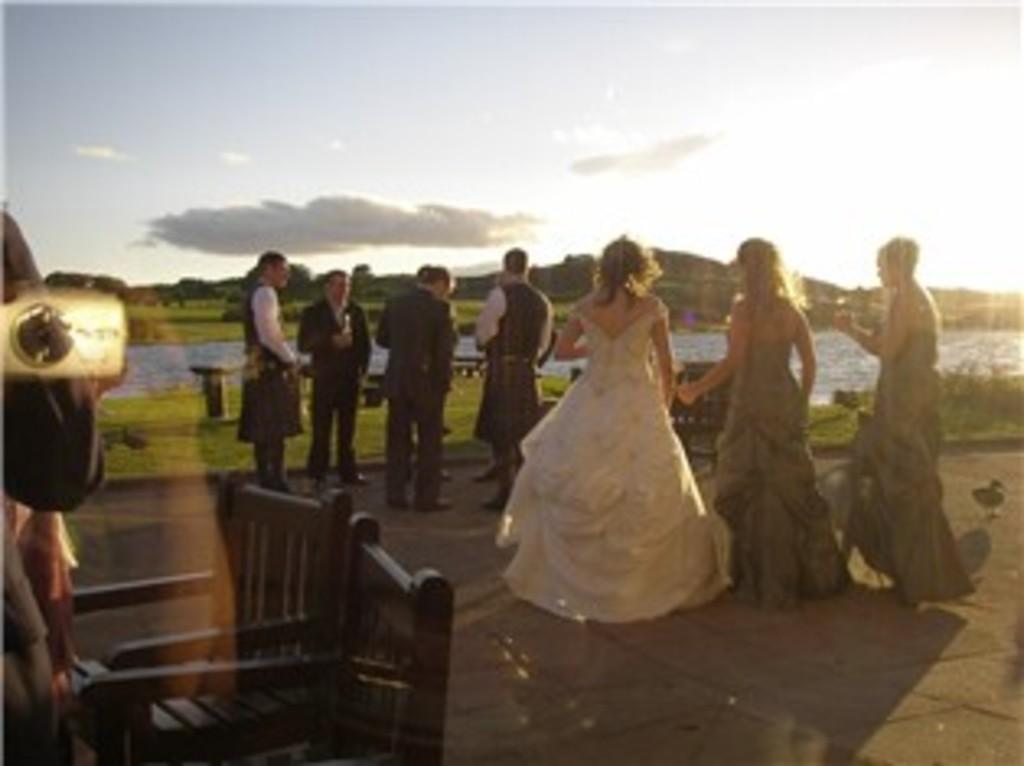Please provide a concise description of this image. In this image I can see the ground, few persons standing, few trees, some grass, the water and few mountains. In the background I can see the sky. 